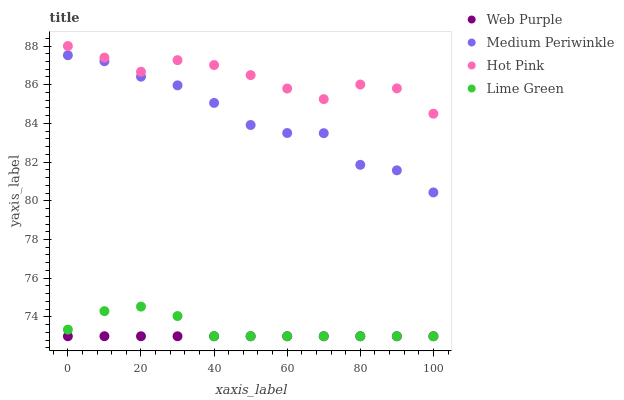Does Web Purple have the minimum area under the curve?
Answer yes or no. Yes. Does Hot Pink have the maximum area under the curve?
Answer yes or no. Yes. Does Hot Pink have the minimum area under the curve?
Answer yes or no. No. Does Web Purple have the maximum area under the curve?
Answer yes or no. No. Is Web Purple the smoothest?
Answer yes or no. Yes. Is Medium Periwinkle the roughest?
Answer yes or no. Yes. Is Hot Pink the smoothest?
Answer yes or no. No. Is Hot Pink the roughest?
Answer yes or no. No. Does Lime Green have the lowest value?
Answer yes or no. Yes. Does Hot Pink have the lowest value?
Answer yes or no. No. Does Hot Pink have the highest value?
Answer yes or no. Yes. Does Web Purple have the highest value?
Answer yes or no. No. Is Lime Green less than Hot Pink?
Answer yes or no. Yes. Is Hot Pink greater than Medium Periwinkle?
Answer yes or no. Yes. Does Lime Green intersect Web Purple?
Answer yes or no. Yes. Is Lime Green less than Web Purple?
Answer yes or no. No. Is Lime Green greater than Web Purple?
Answer yes or no. No. Does Lime Green intersect Hot Pink?
Answer yes or no. No. 